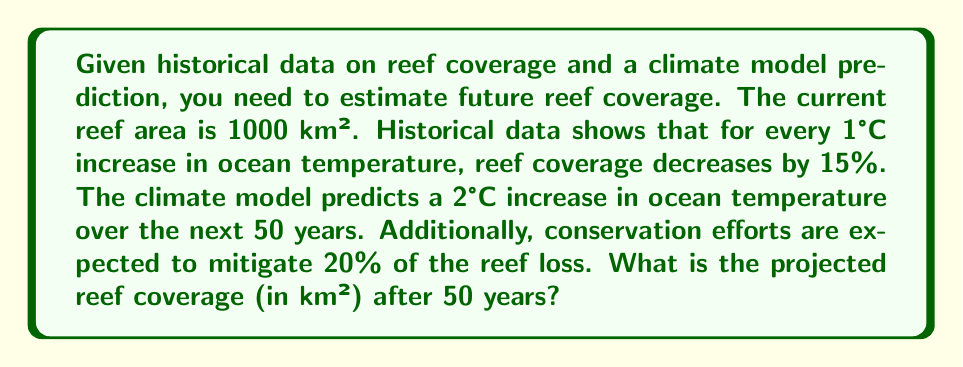Help me with this question. Let's approach this step-by-step:

1) First, calculate the percentage of reef loss without mitigation:
   - For 1°C increase, the loss is 15%
   - For 2°C increase, the loss is $2 \times 15\% = 30\%$

2) Calculate the actual reef loss percentage, considering mitigation:
   - Mitigation reduces loss by 20%
   - Actual loss percentage = $30\% \times (1 - 0.20) = 24\%$

3) Calculate the remaining reef percentage:
   - Remaining percentage = $100\% - 24\% = 76\%$

4) Calculate the projected reef coverage:
   - Current reef area = 1000 km²
   - Projected reef area = $1000 \text{ km}^2 \times 0.76 = 760 \text{ km}^2$

Therefore, the projected reef coverage after 50 years is 760 km².
Answer: 760 km² 